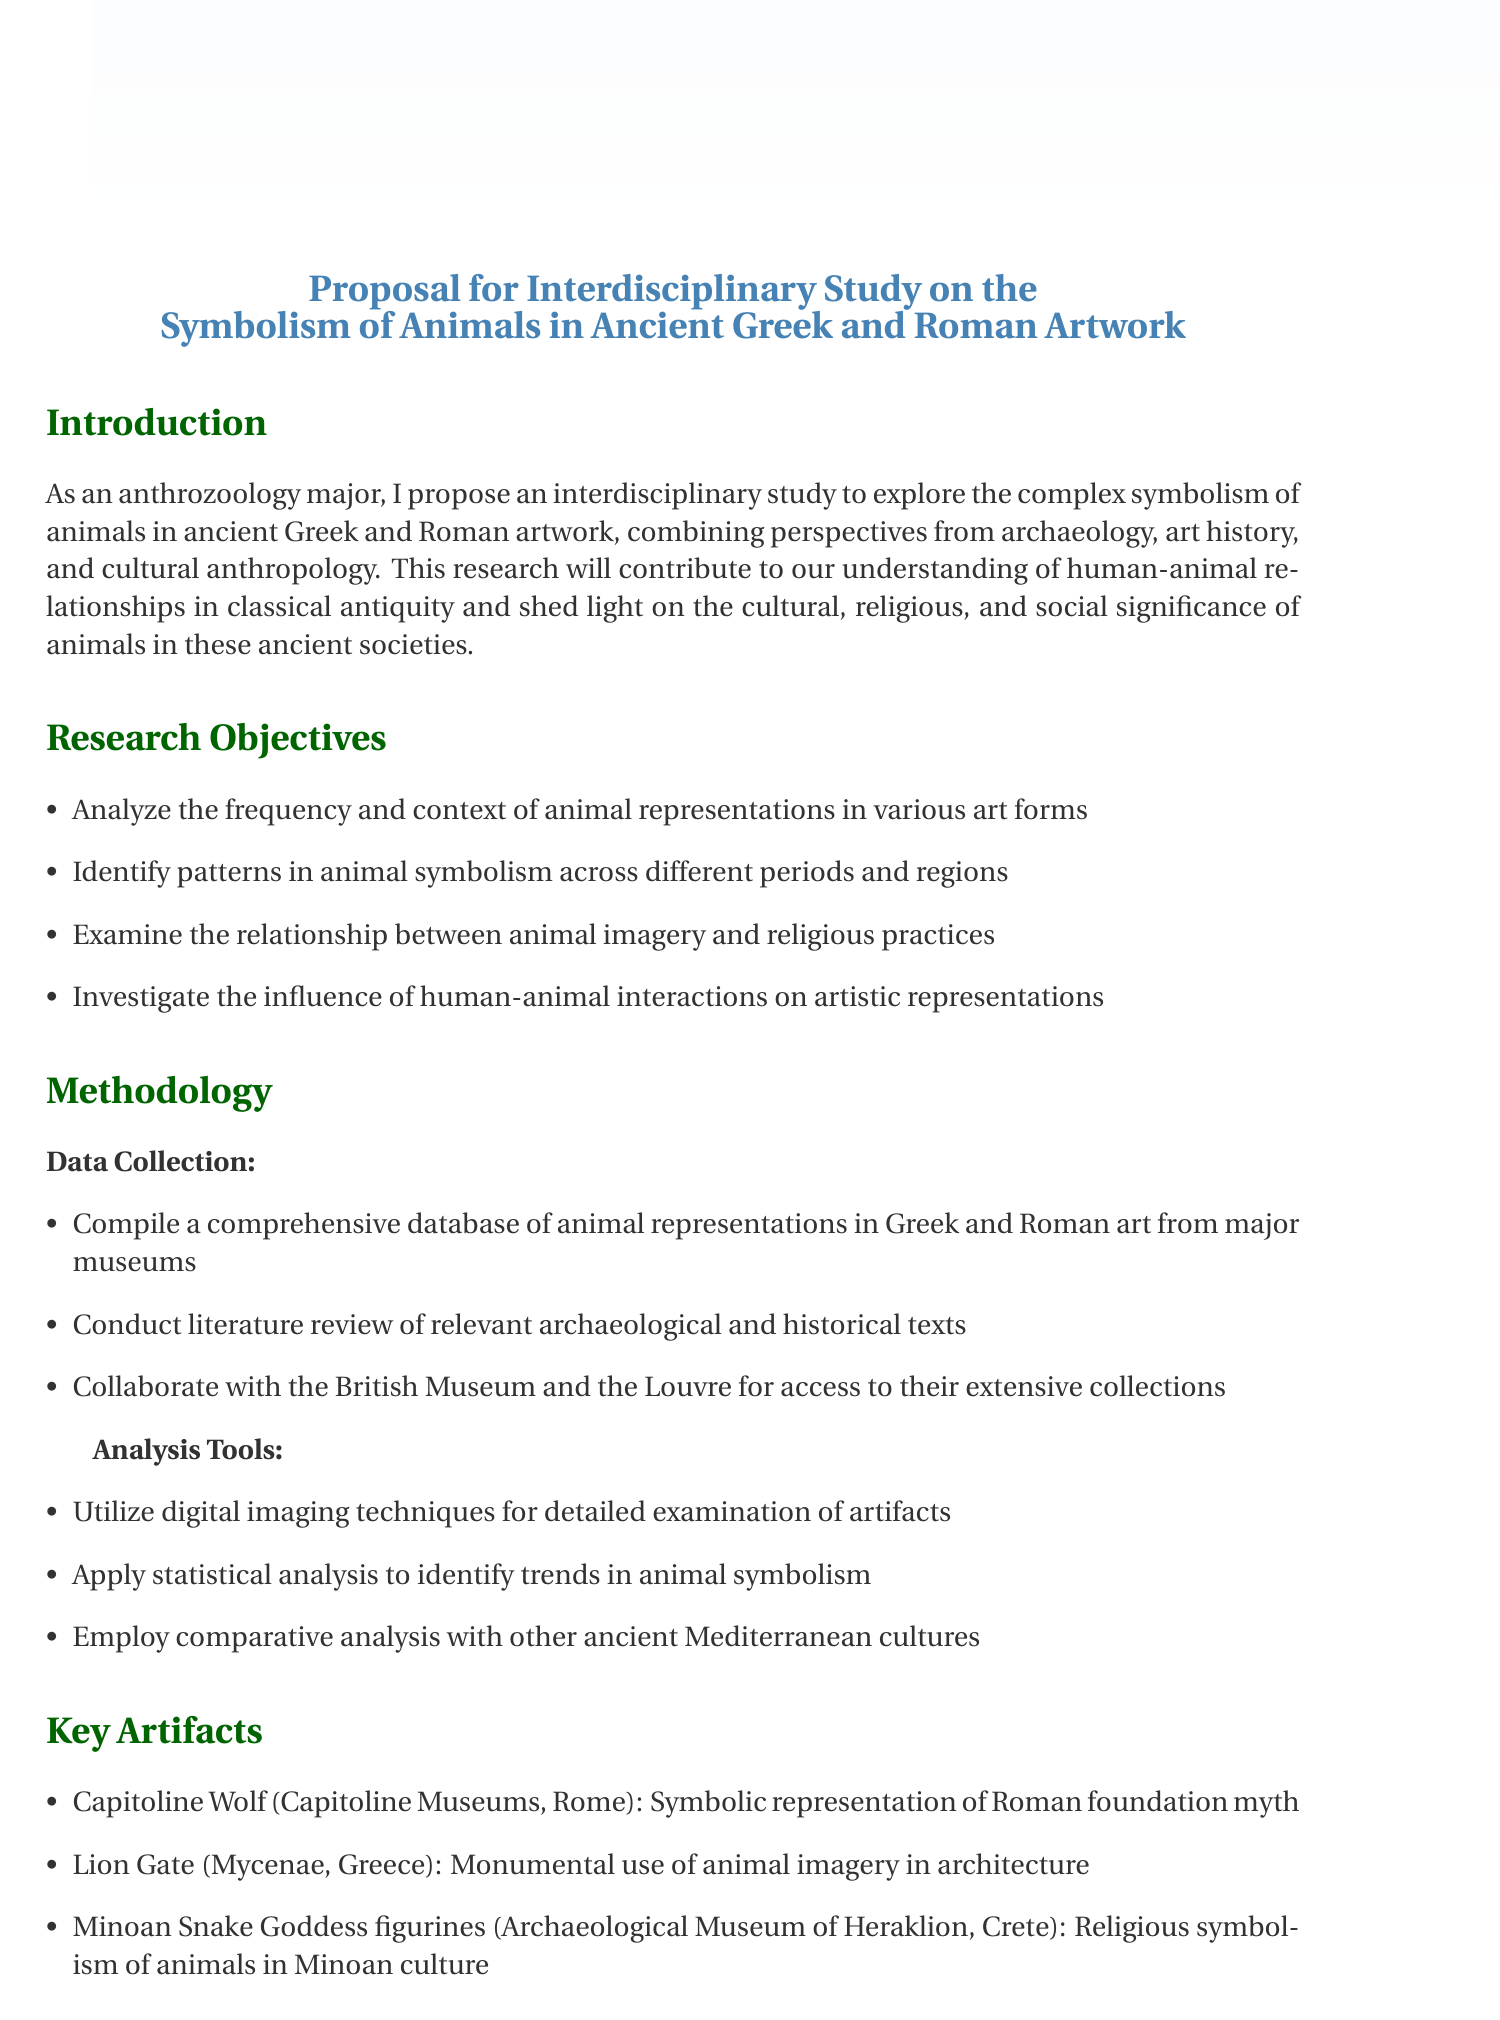What is the total budget for the study? The total budget is listed in the budget overview section of the document.
Answer: 235000 Who is Dr. Emily Chen affiliated with? Dr. Emily Chen's affiliation is provided in the collaborators section of the document.
Answer: Harvard University What is phase 2 of the timeline? Phase 2 details are specified in the timeline section, which outlines different phases of the project.
Answer: Artifact analysis and field research (12 months) What are the key artifacts mentioned in the proposal? The key artifacts are explicitly listed in the key artifacts section of the document.
Answer: Capitoline Wolf, Lion Gate, Minoan Snake Goddess figurines What is one expected outcome of the study? Expected outcomes are listed in the expected outcomes section, detailing the anticipated results of the research.
Answer: A comprehensive database of animal symbolism in Greek and Roman art How long will the literature review and database compilation take? This duration is provided in the timeline section of the proposal.
Answer: 6 months What disciplines are being combined in this study? The disciplines are cited in the introduction, indicating the interdisciplinary nature of the research.
Answer: Archaeology, art history, and cultural anthropology What is the significance of the research? The significance is described in the introduction of the proposal, emphasizing its importance in understanding animal symbolism.
Answer: Understanding human-animal relationships in classical antiquity 